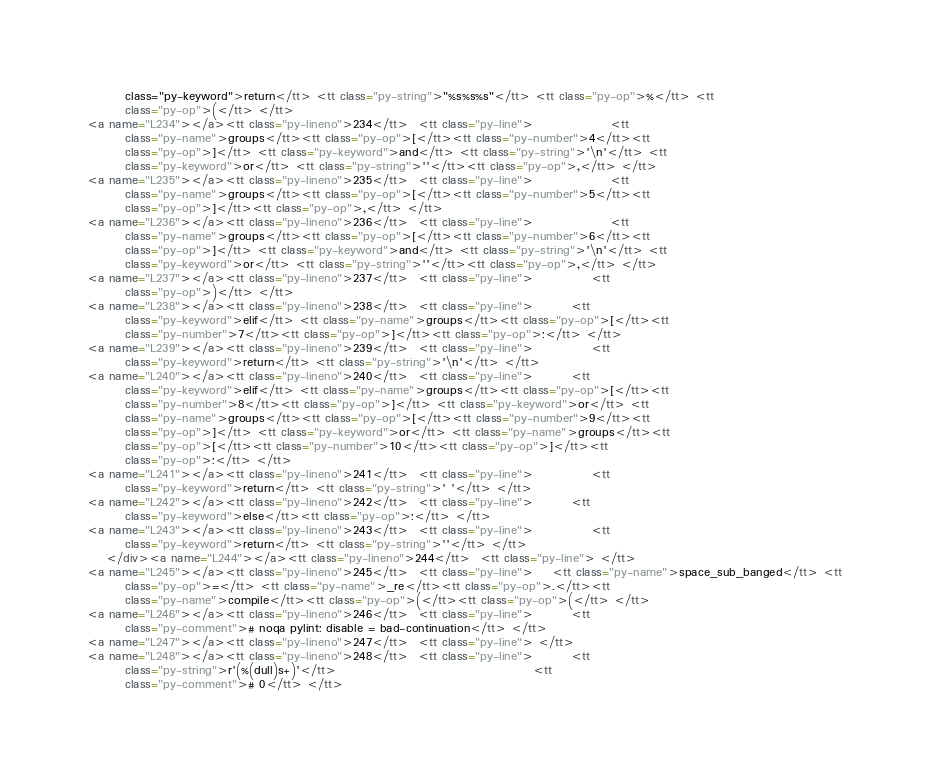<code> <loc_0><loc_0><loc_500><loc_500><_HTML_>        class="py-keyword">return</tt> <tt class="py-string">"%s%s%s"</tt> <tt class="py-op">%</tt> <tt
        class="py-op">(</tt> </tt>
<a name="L234"></a><tt class="py-lineno">234</tt>  <tt class="py-line">                <tt
        class="py-name">groups</tt><tt class="py-op">[</tt><tt class="py-number">4</tt><tt
        class="py-op">]</tt> <tt class="py-keyword">and</tt> <tt class="py-string">'\n'</tt> <tt
        class="py-keyword">or</tt> <tt class="py-string">''</tt><tt class="py-op">,</tt> </tt>
<a name="L235"></a><tt class="py-lineno">235</tt>  <tt class="py-line">                <tt
        class="py-name">groups</tt><tt class="py-op">[</tt><tt class="py-number">5</tt><tt
        class="py-op">]</tt><tt class="py-op">,</tt> </tt>
<a name="L236"></a><tt class="py-lineno">236</tt>  <tt class="py-line">                <tt
        class="py-name">groups</tt><tt class="py-op">[</tt><tt class="py-number">6</tt><tt
        class="py-op">]</tt> <tt class="py-keyword">and</tt> <tt class="py-string">'\n'</tt> <tt
        class="py-keyword">or</tt> <tt class="py-string">''</tt><tt class="py-op">,</tt> </tt>
<a name="L237"></a><tt class="py-lineno">237</tt>  <tt class="py-line">            <tt
        class="py-op">)</tt> </tt>
<a name="L238"></a><tt class="py-lineno">238</tt>  <tt class="py-line">        <tt
        class="py-keyword">elif</tt> <tt class="py-name">groups</tt><tt class="py-op">[</tt><tt
        class="py-number">7</tt><tt class="py-op">]</tt><tt class="py-op">:</tt> </tt>
<a name="L239"></a><tt class="py-lineno">239</tt>  <tt class="py-line">            <tt
        class="py-keyword">return</tt> <tt class="py-string">'\n'</tt> </tt>
<a name="L240"></a><tt class="py-lineno">240</tt>  <tt class="py-line">        <tt
        class="py-keyword">elif</tt> <tt class="py-name">groups</tt><tt class="py-op">[</tt><tt
        class="py-number">8</tt><tt class="py-op">]</tt> <tt class="py-keyword">or</tt> <tt
        class="py-name">groups</tt><tt class="py-op">[</tt><tt class="py-number">9</tt><tt
        class="py-op">]</tt> <tt class="py-keyword">or</tt> <tt class="py-name">groups</tt><tt
        class="py-op">[</tt><tt class="py-number">10</tt><tt class="py-op">]</tt><tt
        class="py-op">:</tt> </tt>
<a name="L241"></a><tt class="py-lineno">241</tt>  <tt class="py-line">            <tt
        class="py-keyword">return</tt> <tt class="py-string">' '</tt> </tt>
<a name="L242"></a><tt class="py-lineno">242</tt>  <tt class="py-line">        <tt
        class="py-keyword">else</tt><tt class="py-op">:</tt> </tt>
<a name="L243"></a><tt class="py-lineno">243</tt>  <tt class="py-line">            <tt
        class="py-keyword">return</tt> <tt class="py-string">''</tt> </tt>
    </div><a name="L244"></a><tt class="py-lineno">244</tt>  <tt class="py-line"> </tt>
<a name="L245"></a><tt class="py-lineno">245</tt>  <tt class="py-line">    <tt class="py-name">space_sub_banged</tt> <tt
        class="py-op">=</tt> <tt class="py-name">_re</tt><tt class="py-op">.</tt><tt
        class="py-name">compile</tt><tt class="py-op">(</tt><tt class="py-op">(</tt> </tt>
<a name="L246"></a><tt class="py-lineno">246</tt>  <tt class="py-line">        <tt
        class="py-comment"># noqa pylint: disable = bad-continuation</tt> </tt>
<a name="L247"></a><tt class="py-lineno">247</tt>  <tt class="py-line"> </tt>
<a name="L248"></a><tt class="py-lineno">248</tt>  <tt class="py-line">        <tt
        class="py-string">r'(%(dull)s+)'</tt>                                         <tt
        class="py-comment"># 0</tt> </tt></code> 